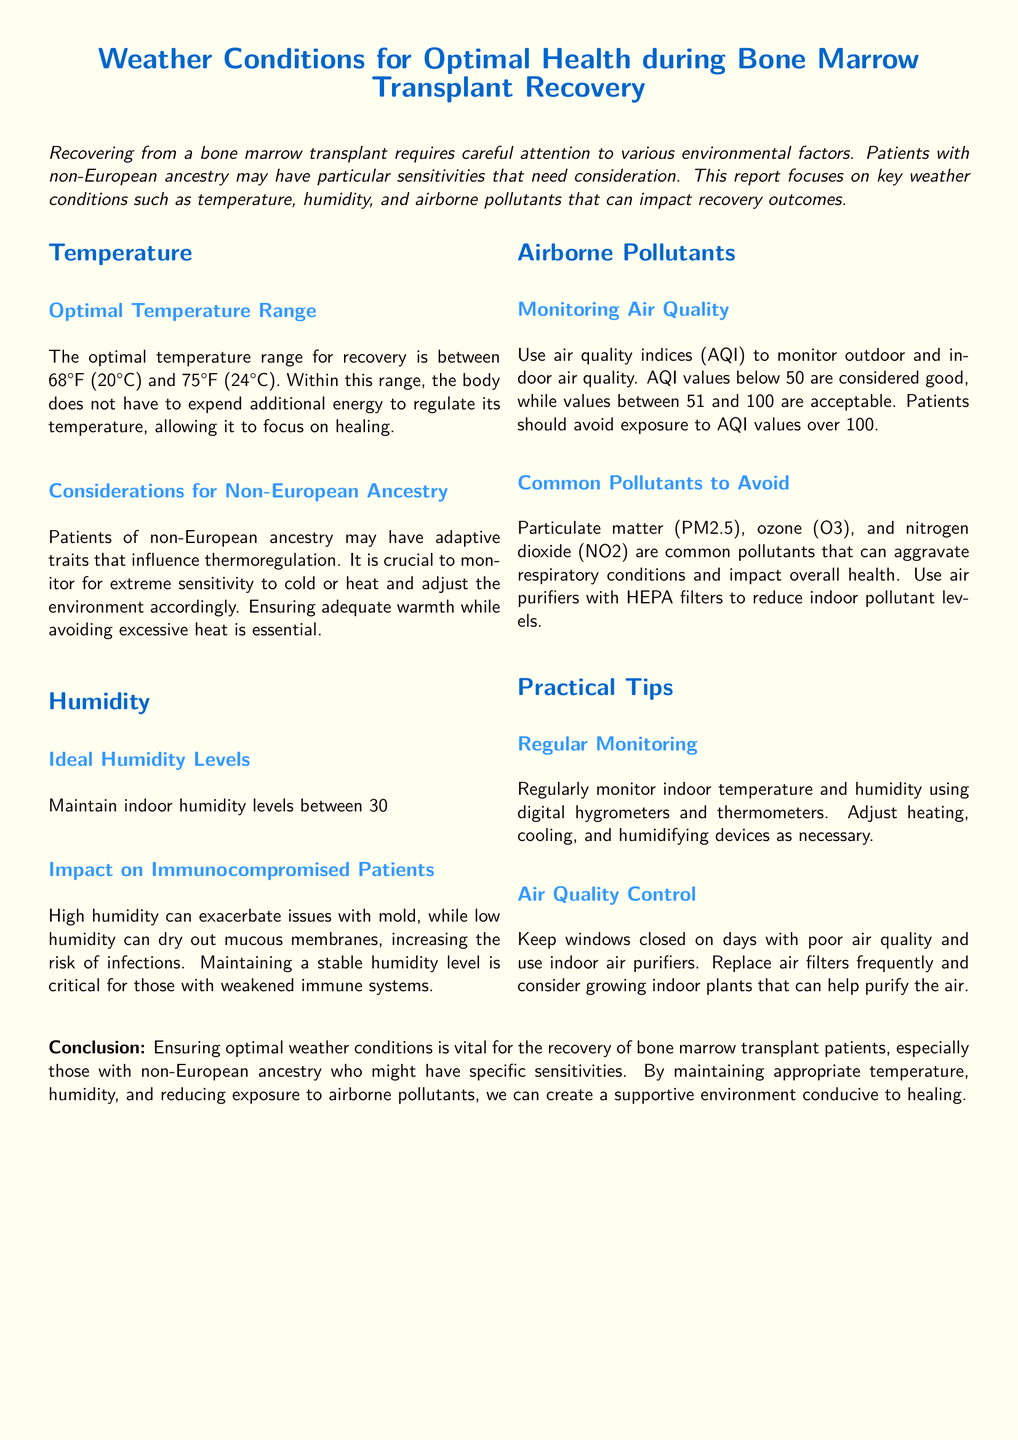What is the optimal temperature range? The optimal temperature range for recovery is specified in the document as between 68°F (20°C) and 75°F (24°C).
Answer: 68°F (20°C) to 75°F (24°C) What humidity levels should be maintained? The document states that indoor humidity levels should be maintained between 30% to 50%.
Answer: 30% to 50% What AQI values are considered good? The document defines that AQI values below 50 are considered good for air quality.
Answer: Below 50 What is a common pollutant mentioned? The document lists particulate matter (PM2.5), ozone (O3), and nitrogen dioxide (NO2) as common pollutants to avoid.
Answer: Particulate matter (PM2.5) What impact does high humidity have on health? The document indicates that high humidity can exacerbate issues with mold, impacting the health of immunocompromised patients.
Answer: Exacerbate issues with mold Why is temperature regulation important during recovery? According to the document, regulating temperature helps the body to focus on healing rather than expending energy to maintain temperature.
Answer: Focus on healing What should be used to monitor indoor climate? The document suggests using digital hygrometers and thermometers to monitor indoor temperature and humidity levels.
Answer: Digital hygrometers and thermometers What is recommended for air quality control? It is recommended to keep windows closed and use indoor air purifiers on days with poor air quality.
Answer: Keep windows closed and use indoor air purifiers What type of filter is suggested for air purifiers? The document recommends using air purifiers with HEPA filters to reduce indoor pollutant levels.
Answer: HEPA filters 